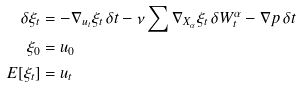<formula> <loc_0><loc_0><loc_500><loc_500>\delta \xi _ { t } & = - \nabla _ { u _ { t } } \xi _ { t } \, \delta t - \nu \sum \nabla _ { X _ { \alpha } } \xi _ { t } \, \delta W _ { t } ^ { \alpha } - \nabla p \, \delta t \\ \xi _ { 0 } & = u _ { 0 } \\ E [ \xi _ { t } ] & = u _ { t }</formula> 